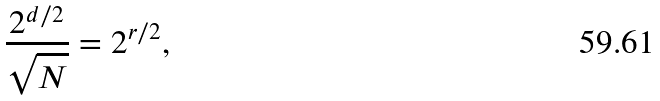<formula> <loc_0><loc_0><loc_500><loc_500>\frac { 2 ^ { d / 2 } } { \sqrt { N } } = 2 ^ { r / 2 } ,</formula> 